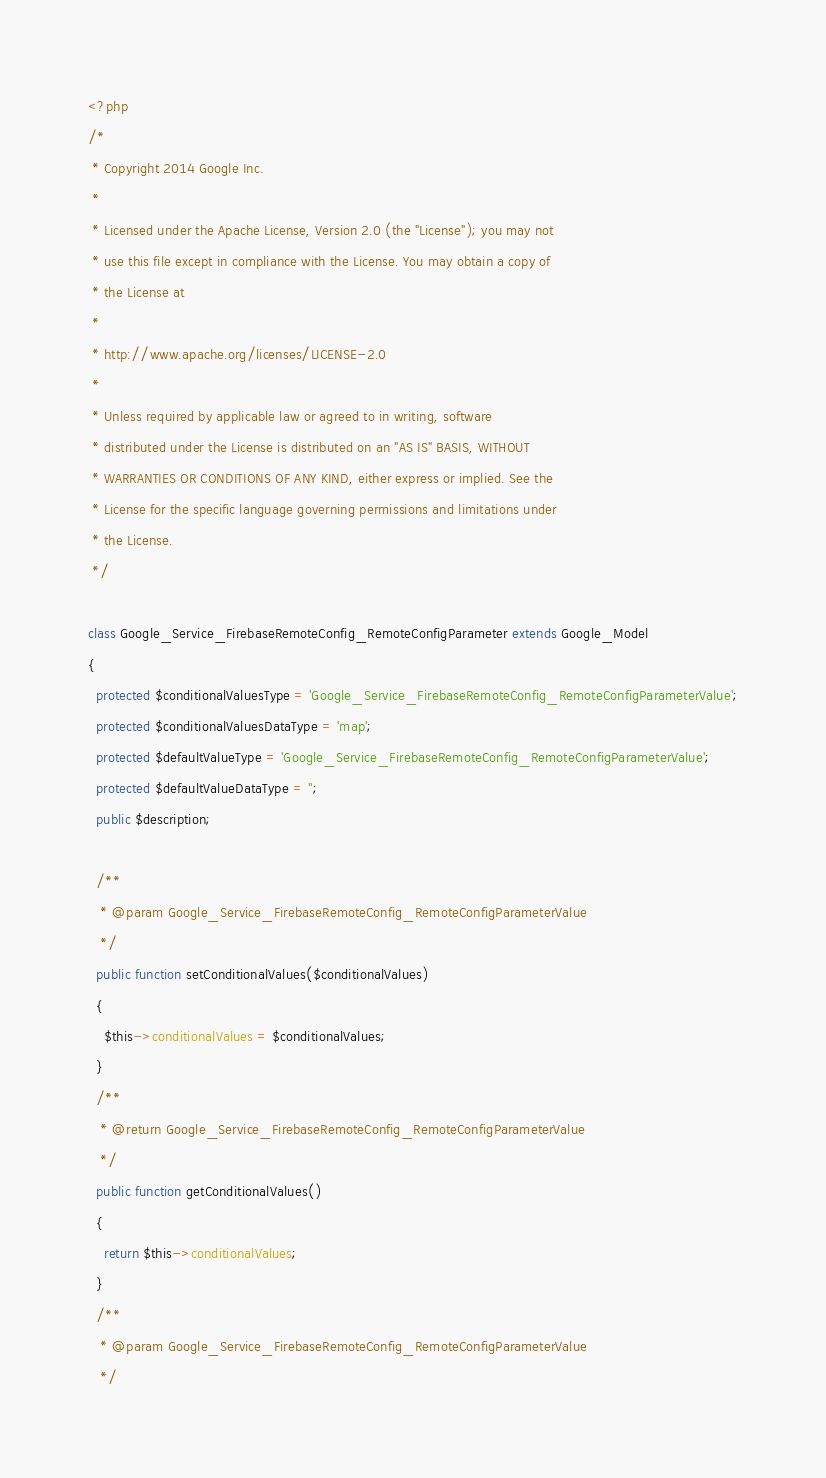<code> <loc_0><loc_0><loc_500><loc_500><_PHP_><?php
/*
 * Copyright 2014 Google Inc.
 *
 * Licensed under the Apache License, Version 2.0 (the "License"); you may not
 * use this file except in compliance with the License. You may obtain a copy of
 * the License at
 *
 * http://www.apache.org/licenses/LICENSE-2.0
 *
 * Unless required by applicable law or agreed to in writing, software
 * distributed under the License is distributed on an "AS IS" BASIS, WITHOUT
 * WARRANTIES OR CONDITIONS OF ANY KIND, either express or implied. See the
 * License for the specific language governing permissions and limitations under
 * the License.
 */

class Google_Service_FirebaseRemoteConfig_RemoteConfigParameter extends Google_Model
{
  protected $conditionalValuesType = 'Google_Service_FirebaseRemoteConfig_RemoteConfigParameterValue';
  protected $conditionalValuesDataType = 'map';
  protected $defaultValueType = 'Google_Service_FirebaseRemoteConfig_RemoteConfigParameterValue';
  protected $defaultValueDataType = '';
  public $description;

  /**
   * @param Google_Service_FirebaseRemoteConfig_RemoteConfigParameterValue
   */
  public function setConditionalValues($conditionalValues)
  {
    $this->conditionalValues = $conditionalValues;
  }
  /**
   * @return Google_Service_FirebaseRemoteConfig_RemoteConfigParameterValue
   */
  public function getConditionalValues()
  {
    return $this->conditionalValues;
  }
  /**
   * @param Google_Service_FirebaseRemoteConfig_RemoteConfigParameterValue
   */</code> 